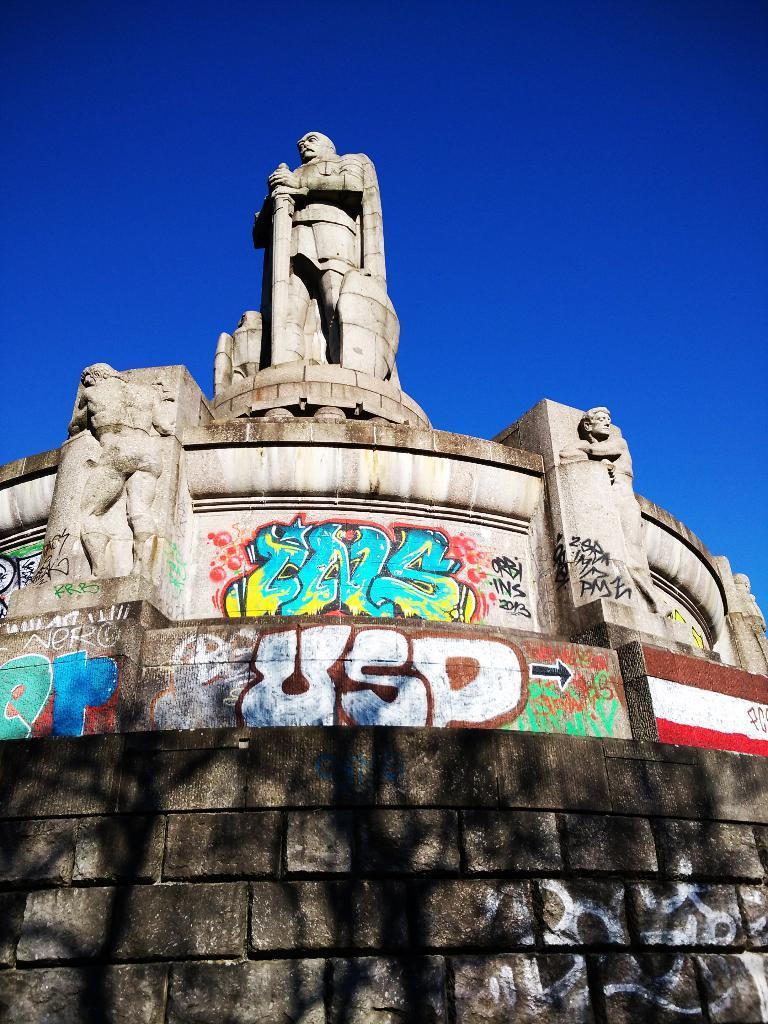In one or two sentences, can you explain what this image depicts? In this image we can see one big statue, on wall, some text on the wall, one flag painted on the wall and at the top there is the blue sky. 